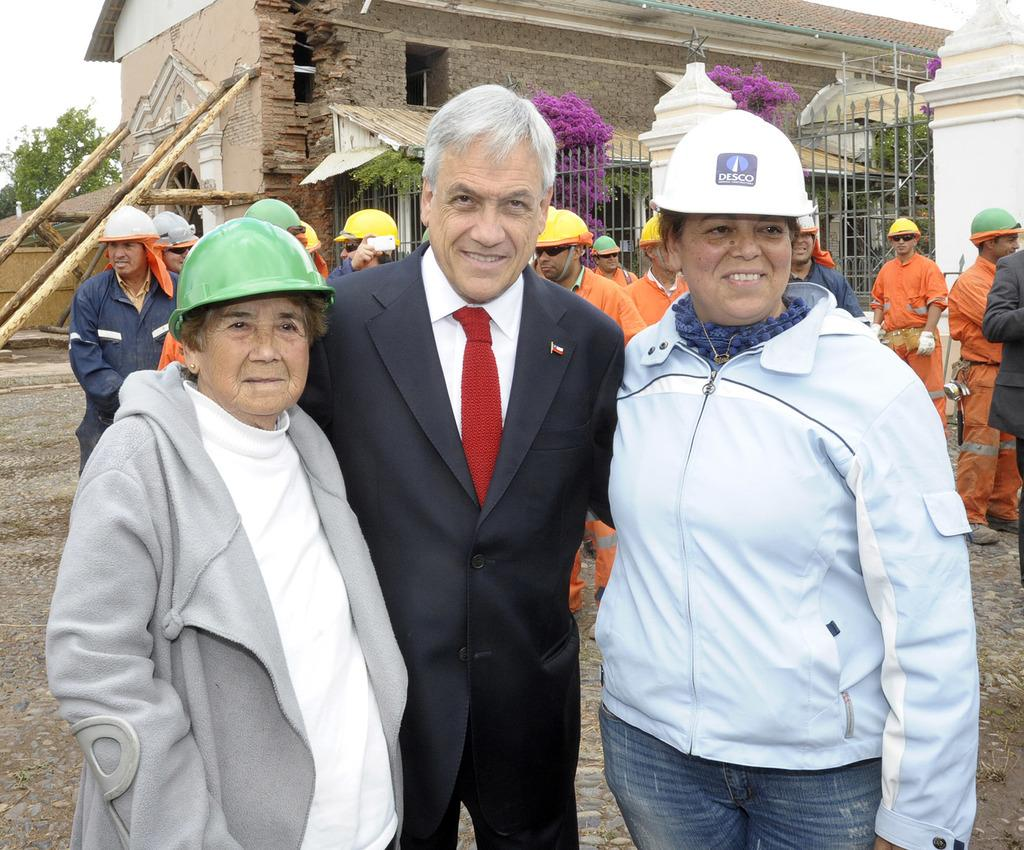How many people are in the image? There are three people in the image: two women and an old man. What are the women wearing in the image? The women are wearing jackets in the image. What is the old man wearing in the image? The old man is wearing a suit in the image. Where are the women and the old man located in the image? They are standing in the middle of the image. What can be seen in the background of the image? There are men constructing a building in the background of the image. What grade is the potato in the image? There is no potato present in the image. 